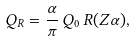Convert formula to latex. <formula><loc_0><loc_0><loc_500><loc_500>Q _ { R } = { \frac { \alpha } { \pi } } \, Q _ { 0 } \, R ( Z \alpha ) ,</formula> 